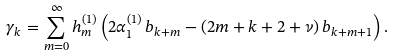<formula> <loc_0><loc_0><loc_500><loc_500>\gamma _ { k } = \sum _ { m = 0 } ^ { \infty } h _ { m } ^ { ( 1 ) } \left ( 2 \alpha _ { 1 } ^ { ( 1 ) } \, b _ { k + m } - ( 2 m + k + 2 + \nu ) \, b _ { k + m + 1 } \right ) .</formula> 